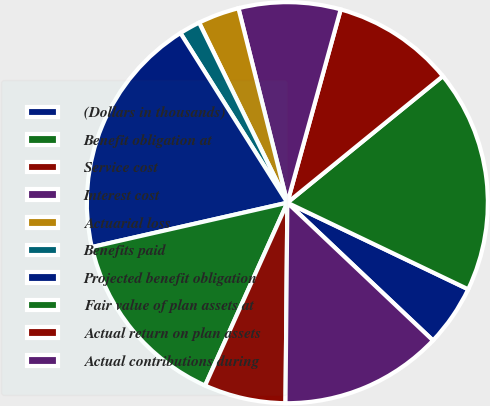<chart> <loc_0><loc_0><loc_500><loc_500><pie_chart><fcel>(Dollars in thousands)<fcel>Benefit obligation at<fcel>Service cost<fcel>Interest cost<fcel>Actuarial loss<fcel>Benefits paid<fcel>Projected benefit obligation<fcel>Fair value of plan assets at<fcel>Actual return on plan assets<fcel>Actual contributions during<nl><fcel>4.95%<fcel>17.98%<fcel>9.84%<fcel>8.21%<fcel>3.33%<fcel>1.7%<fcel>19.6%<fcel>14.72%<fcel>6.58%<fcel>13.09%<nl></chart> 